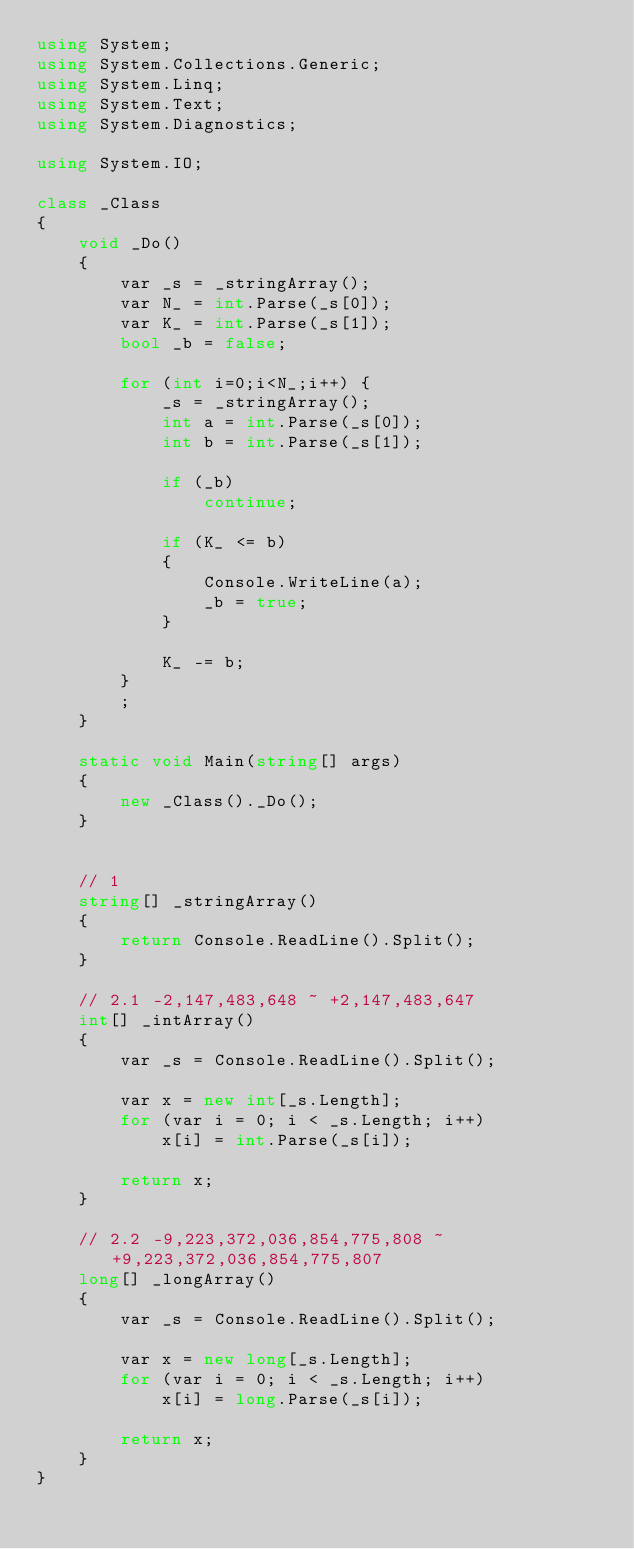<code> <loc_0><loc_0><loc_500><loc_500><_C#_>using System;
using System.Collections.Generic;
using System.Linq;
using System.Text;
using System.Diagnostics;

using System.IO;

class _Class
{
	void _Do()
	{
		var _s = _stringArray();
		var N_ = int.Parse(_s[0]);
		var K_ = int.Parse(_s[1]);
		bool _b = false;

		for (int i=0;i<N_;i++) {
			_s = _stringArray();
			int a = int.Parse(_s[0]);
			int b = int.Parse(_s[1]);

			if (_b)
				continue;

			if (K_ <= b)
			{
				Console.WriteLine(a);
				_b = true;
			}
			
			K_ -= b;
		}
		;
	}

	static void Main(string[] args)
	{
		new _Class()._Do();
	}


	// 1
	string[] _stringArray()
	{
		return Console.ReadLine().Split();
	}

	// 2.1 -2,147,483,648 ~ +2,147,483,647
	int[] _intArray()
	{
		var _s = Console.ReadLine().Split();

		var x = new int[_s.Length];
		for (var i = 0; i < _s.Length; i++)
			x[i] = int.Parse(_s[i]);

		return x;
	}

	// 2.2 -9,223,372,036,854,775,808 ~ +9,223,372,036,854,775,807
	long[] _longArray()
	{
		var _s = Console.ReadLine().Split();

		var x = new long[_s.Length];
		for (var i = 0; i < _s.Length; i++)
			x[i] = long.Parse(_s[i]);

		return x;
	}
}
</code> 